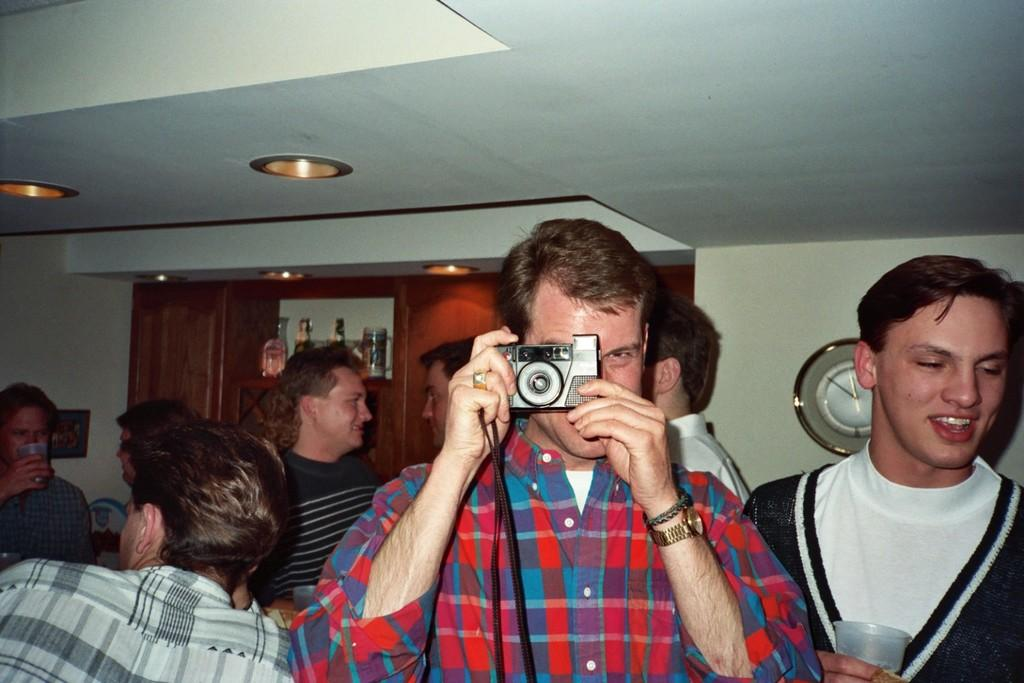What is the main subject of the image? The main subject of the image is a group of men. Where are the men located in the image? The men are in a hall. What is one of the men doing in the image? One man is taking a picture with a camera. What type of canvas is being used by the men in the image? There is no canvas present in the image; the men are in a hall and one of them is taking a picture with a camera. 